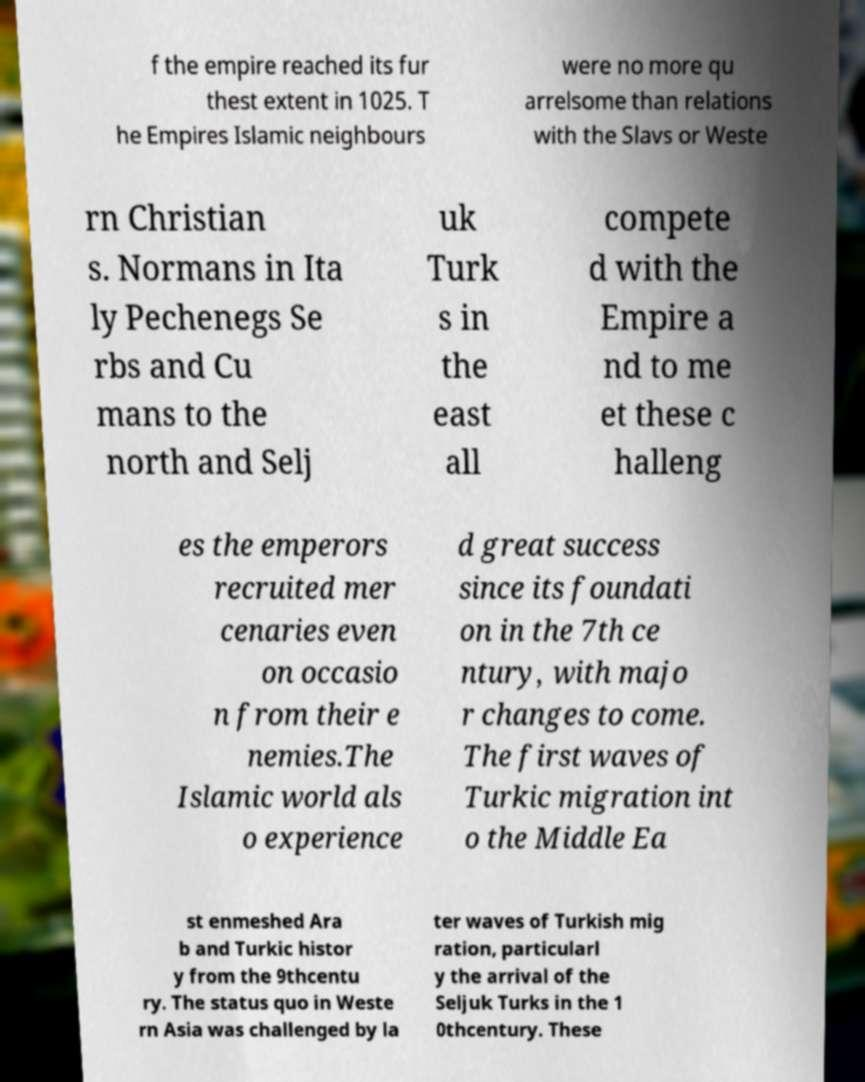Can you read and provide the text displayed in the image?This photo seems to have some interesting text. Can you extract and type it out for me? f the empire reached its fur thest extent in 1025. T he Empires Islamic neighbours were no more qu arrelsome than relations with the Slavs or Weste rn Christian s. Normans in Ita ly Pechenegs Se rbs and Cu mans to the north and Selj uk Turk s in the east all compete d with the Empire a nd to me et these c halleng es the emperors recruited mer cenaries even on occasio n from their e nemies.The Islamic world als o experience d great success since its foundati on in the 7th ce ntury, with majo r changes to come. The first waves of Turkic migration int o the Middle Ea st enmeshed Ara b and Turkic histor y from the 9thcentu ry. The status quo in Weste rn Asia was challenged by la ter waves of Turkish mig ration, particularl y the arrival of the Seljuk Turks in the 1 0thcentury. These 